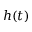Convert formula to latex. <formula><loc_0><loc_0><loc_500><loc_500>h ( t )</formula> 